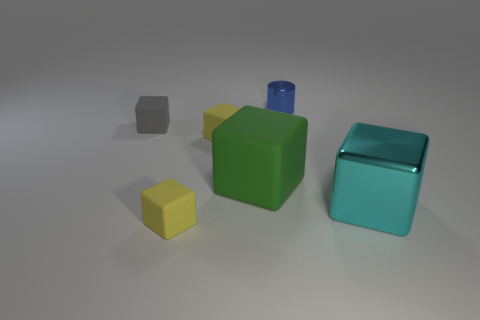Subtract all yellow blocks. How many blocks are left? 3 Subtract all large cyan shiny blocks. How many blocks are left? 4 Subtract 3 blocks. How many blocks are left? 2 Add 1 blue metallic cylinders. How many objects exist? 7 Subtract all green balls. How many purple cylinders are left? 0 Add 5 large green objects. How many large green objects exist? 6 Subtract 0 brown cylinders. How many objects are left? 6 Subtract all cubes. How many objects are left? 1 Subtract all brown blocks. Subtract all blue cylinders. How many blocks are left? 5 Subtract all big metal things. Subtract all small gray matte blocks. How many objects are left? 4 